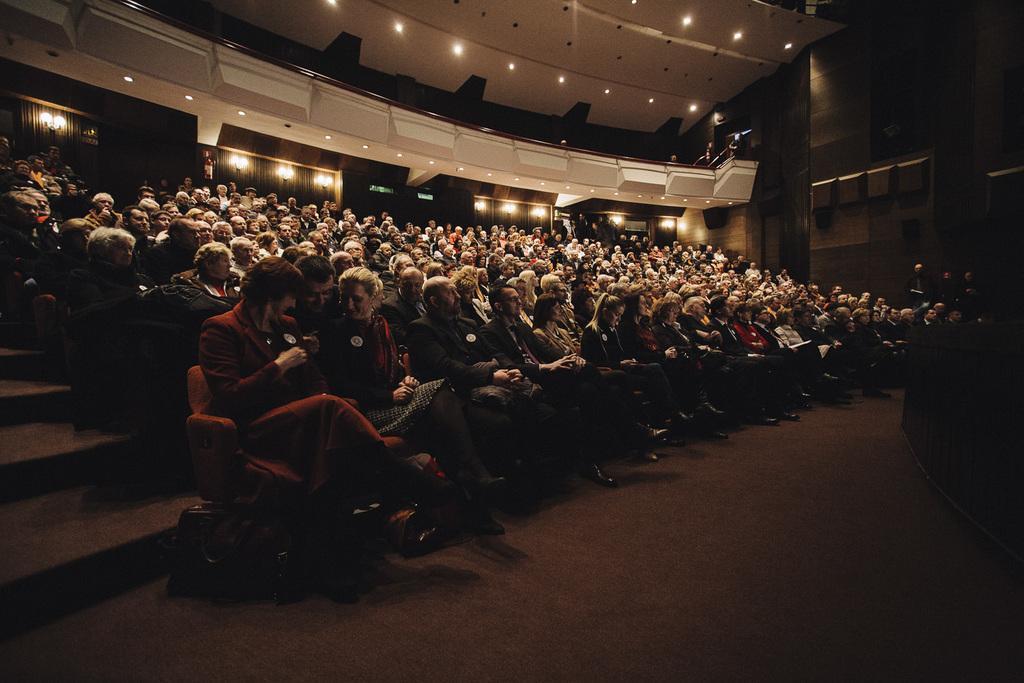In one or two sentences, can you explain what this image depicts? This image consists of a huge crowd sitting in the chairs. It looks like an auditorium. At the bottom, there is a floor. On the left, there are steps. At the top, we can see a balcony along with the lights. 